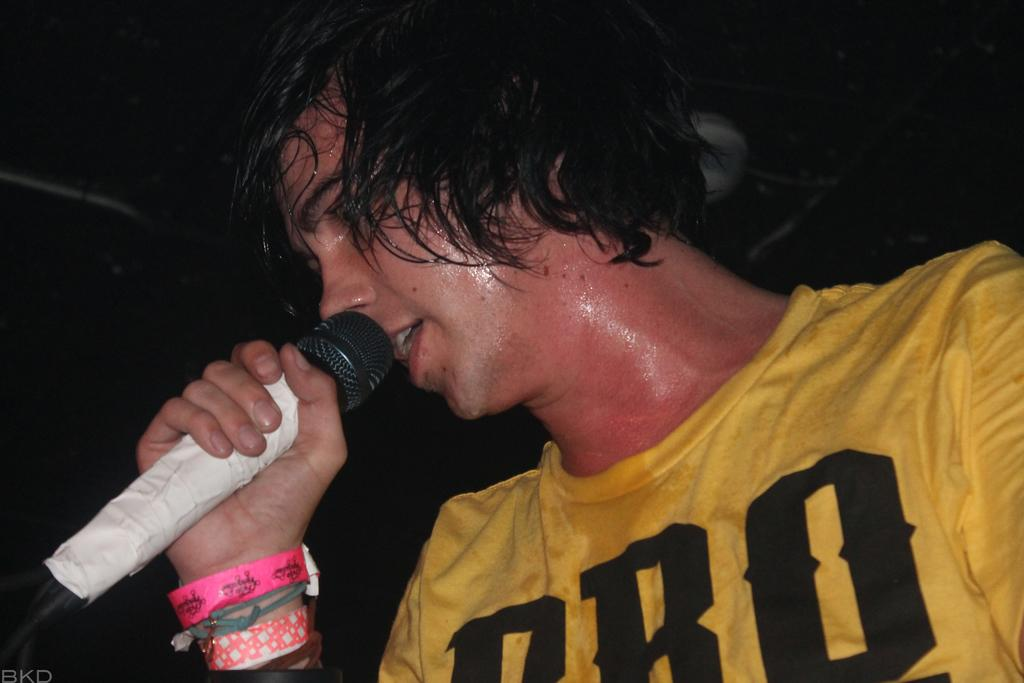What is the main subject of the image? The main subject of the image is a man. What is the man doing in the image? The man is singing in the image. What object is the man holding while singing? The man is holding a microphone in the image. What color is the t-shirt the man is wearing? The man is wearing a yellow color t-shirt in the image. Can you see a loaf of bread in the image? No, there is no loaf of bread present in the image. Is the man standing on a slope while singing? There is no indication of a slope in the image; the man is likely standing on a flat surface. 